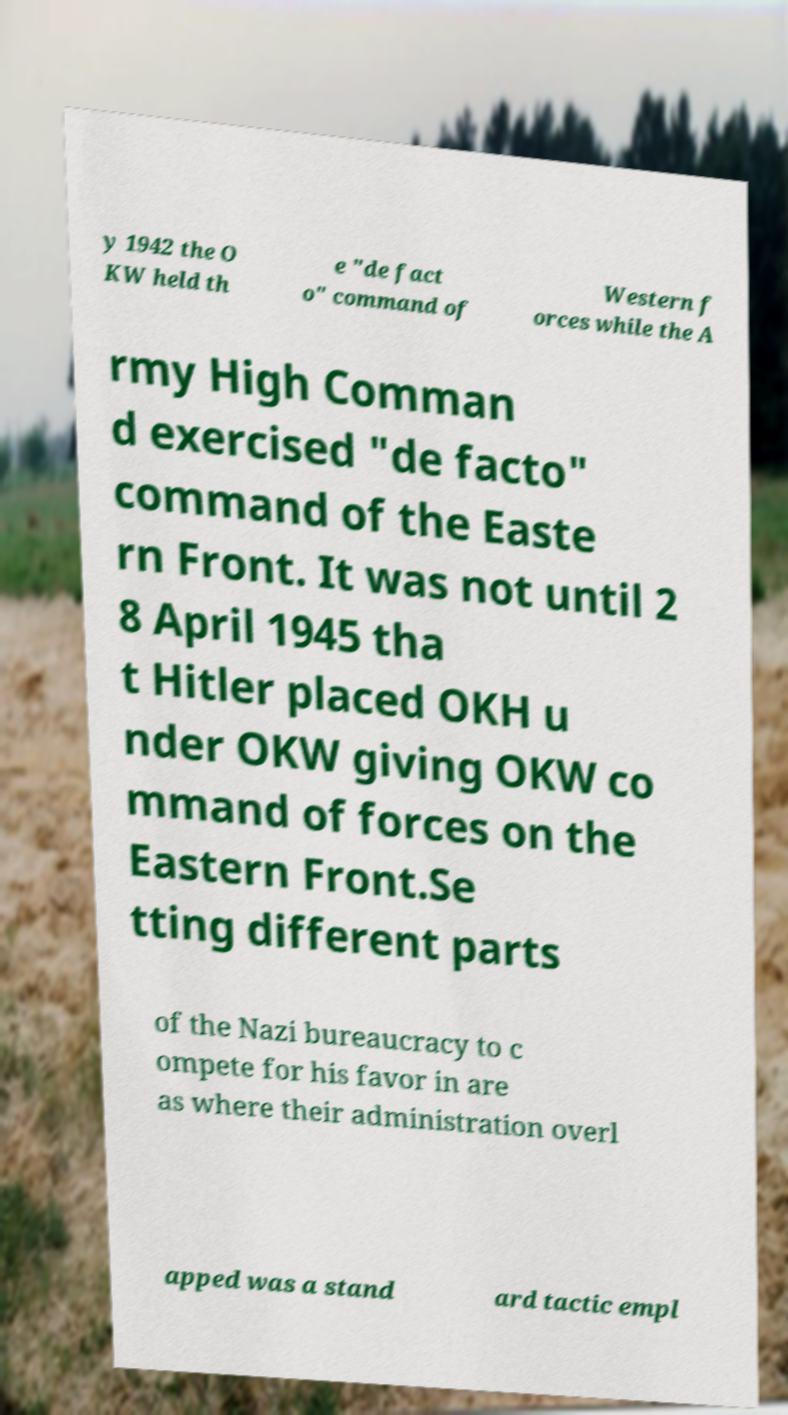For documentation purposes, I need the text within this image transcribed. Could you provide that? y 1942 the O KW held th e "de fact o" command of Western f orces while the A rmy High Comman d exercised "de facto" command of the Easte rn Front. It was not until 2 8 April 1945 tha t Hitler placed OKH u nder OKW giving OKW co mmand of forces on the Eastern Front.Se tting different parts of the Nazi bureaucracy to c ompete for his favor in are as where their administration overl apped was a stand ard tactic empl 